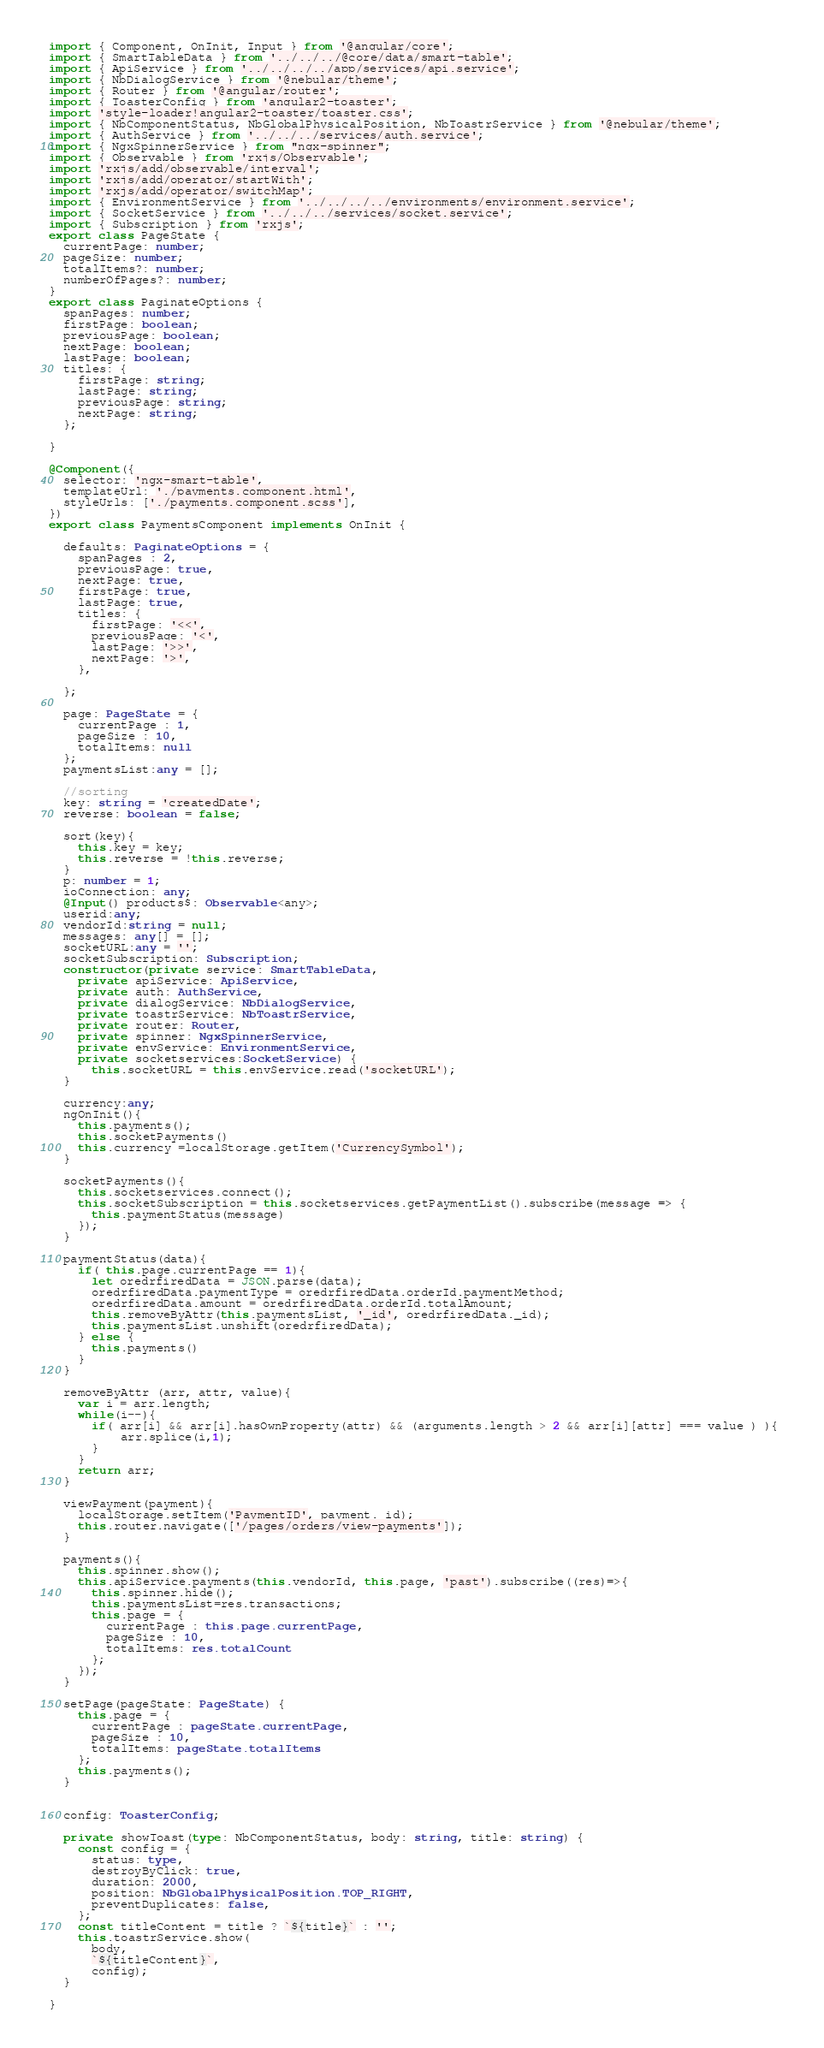<code> <loc_0><loc_0><loc_500><loc_500><_TypeScript_>import { Component, OnInit, Input } from '@angular/core';
import { SmartTableData } from '../../../@core/data/smart-table';
import { ApiService } from '../../../../app/services/api.service';
import { NbDialogService } from '@nebular/theme';
import { Router } from '@angular/router';
import { ToasterConfig } from 'angular2-toaster';
import 'style-loader!angular2-toaster/toaster.css';
import { NbComponentStatus, NbGlobalPhysicalPosition, NbToastrService } from '@nebular/theme';
import { AuthService } from '../../../services/auth.service';
import { NgxSpinnerService } from "ngx-spinner";
import { Observable } from 'rxjs/Observable';
import 'rxjs/add/observable/interval';
import 'rxjs/add/operator/startWith';
import 'rxjs/add/operator/switchMap';
import { EnvironmentService } from '../../../../environments/environment.service';
import { SocketService } from '../../../services/socket.service';
import { Subscription } from 'rxjs';
export class PageState {
  currentPage: number;
  pageSize: number;
  totalItems?: number;
  numberOfPages?: number;
} 
export class PaginateOptions {
  spanPages: number;
  firstPage: boolean;
  previousPage: boolean;
  nextPage: boolean;
  lastPage: boolean;
  titles: {
    firstPage: string;
    lastPage: string;
    previousPage: string;
    nextPage: string;
  };

}

@Component({
  selector: 'ngx-smart-table',
  templateUrl: './payments.component.html',
  styleUrls: ['./payments.component.scss'],
})
export class PaymentsComponent implements OnInit {
  
  defaults: PaginateOptions = {
    spanPages : 2,
    previousPage: true,
    nextPage: true,
    firstPage: true,
    lastPage: true,
    titles: {
      firstPage: '<<',
      previousPage: '<',
      lastPage: '>>',
      nextPage: '>',
    },
   
  };
  
  page: PageState = {
    currentPage : 1,
    pageSize : 10,
    totalItems: null
  };
  paymentsList:any = [];
  
  //sorting
  key: string = 'createdDate';
  reverse: boolean = false;

  sort(key){
    this.key = key;
    this.reverse = !this.reverse;
  }
  p: number = 1;
  ioConnection: any;
  @Input() products$: Observable<any>;
  userid:any;
  vendorId:string = null;
  messages: any[] = [];
  socketURL:any = '';
  socketSubscription: Subscription;
  constructor(private service: SmartTableData, 
    private apiService: ApiService,
    private auth: AuthService,
    private dialogService: NbDialogService,
    private toastrService: NbToastrService,
    private router: Router,
    private spinner: NgxSpinnerService,
    private envService: EnvironmentService,
    private socketservices:SocketService) {
      this.socketURL = this.envService.read('socketURL');
  }

  currency:any;
  ngOnInit(){
    this.payments();
    this.socketPayments()
    this.currency =localStorage.getItem('CurrencySymbol');
  }

  socketPayments(){
    this.socketservices.connect();
    this.socketSubscription = this.socketservices.getPaymentList().subscribe(message => {
      this.paymentStatus(message)
    });
  }

  paymentStatus(data){
    if( this.page.currentPage == 1){
      let oredrfiredData = JSON.parse(data);
      oredrfiredData.paymentType = oredrfiredData.orderId.paymentMethod;
      oredrfiredData.amount = oredrfiredData.orderId.totalAmount;
      this.removeByAttr(this.paymentsList, '_id', oredrfiredData._id); 
      this.paymentsList.unshift(oredrfiredData);
    } else {
      this.payments()
    }
  }

  removeByAttr (arr, attr, value){
    var i = arr.length;
    while(i--){
      if( arr[i] && arr[i].hasOwnProperty(attr) && (arguments.length > 2 && arr[i][attr] === value ) ){ 
          arr.splice(i,1);
      }
    }
    return arr;
  }

  viewPayment(payment){
    localStorage.setItem('PaymentID', payment._id);
    this.router.navigate(['/pages/orders/view-payments']); 
  }

  payments(){
    this.spinner.show();
    this.apiService.payments(this.vendorId, this.page, 'past').subscribe((res)=>{
      this.spinner.hide();
      this.paymentsList=res.transactions;
      this.page = {
        currentPage : this.page.currentPage,
        pageSize : 10,
        totalItems: res.totalCount
      };
    });  
  }

  setPage(pageState: PageState) {
    this.page = {
      currentPage : pageState.currentPage,
      pageSize : 10,
      totalItems: pageState.totalItems
    };
    this.payments();
  }
  
  
  config: ToasterConfig;

  private showToast(type: NbComponentStatus, body: string, title: string) {
    const config = {
      status: type,
      destroyByClick: true,
      duration: 2000,
      position: NbGlobalPhysicalPosition.TOP_RIGHT,
      preventDuplicates: false,
    };
    const titleContent = title ? `${title}` : '';
    this.toastrService.show(
      body,
      `${titleContent}`,
      config);
  }

}
</code> 